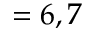<formula> <loc_0><loc_0><loc_500><loc_500>= 6 , 7</formula> 